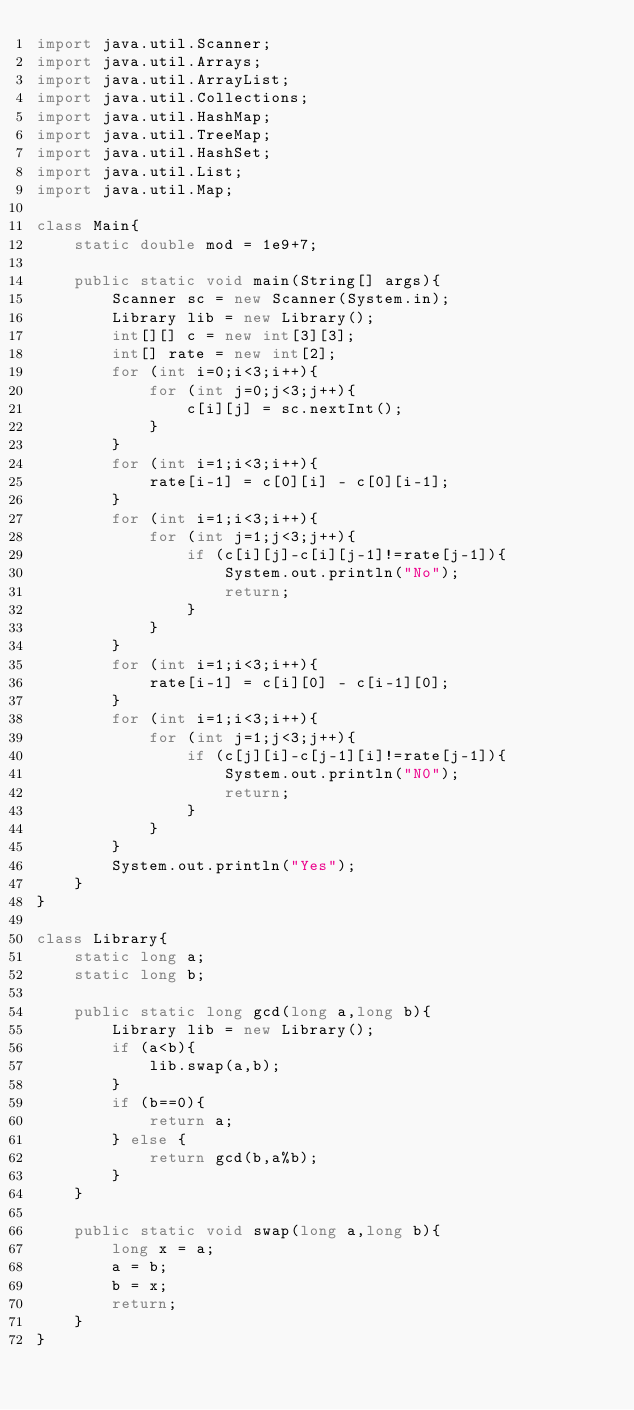Convert code to text. <code><loc_0><loc_0><loc_500><loc_500><_Java_>import java.util.Scanner;
import java.util.Arrays;
import java.util.ArrayList;
import java.util.Collections;
import java.util.HashMap;
import java.util.TreeMap;
import java.util.HashSet;
import java.util.List;
import java.util.Map;

class Main{
    static double mod = 1e9+7;

    public static void main(String[] args){
        Scanner sc = new Scanner(System.in);
        Library lib = new Library();
        int[][] c = new int[3][3];
        int[] rate = new int[2];
        for (int i=0;i<3;i++){
            for (int j=0;j<3;j++){
                c[i][j] = sc.nextInt();
            }
        }
        for (int i=1;i<3;i++){
            rate[i-1] = c[0][i] - c[0][i-1];
        }
        for (int i=1;i<3;i++){
            for (int j=1;j<3;j++){
                if (c[i][j]-c[i][j-1]!=rate[j-1]){
                    System.out.println("No");
                    return;
                }
            }
        }
        for (int i=1;i<3;i++){
            rate[i-1] = c[i][0] - c[i-1][0];
        }
        for (int i=1;i<3;i++){
            for (int j=1;j<3;j++){
                if (c[j][i]-c[j-1][i]!=rate[j-1]){
                    System.out.println("N0");
                    return;
                }
            }
        }
        System.out.println("Yes");
    }
}

class Library{
    static long a;
    static long b;

    public static long gcd(long a,long b){
        Library lib = new Library();
        if (a<b){
            lib.swap(a,b);
        }
        if (b==0){
            return a;
        } else {
            return gcd(b,a%b);
        }
    }

    public static void swap(long a,long b){
        long x = a;
        a = b;
        b = x;
        return;
    }
}</code> 